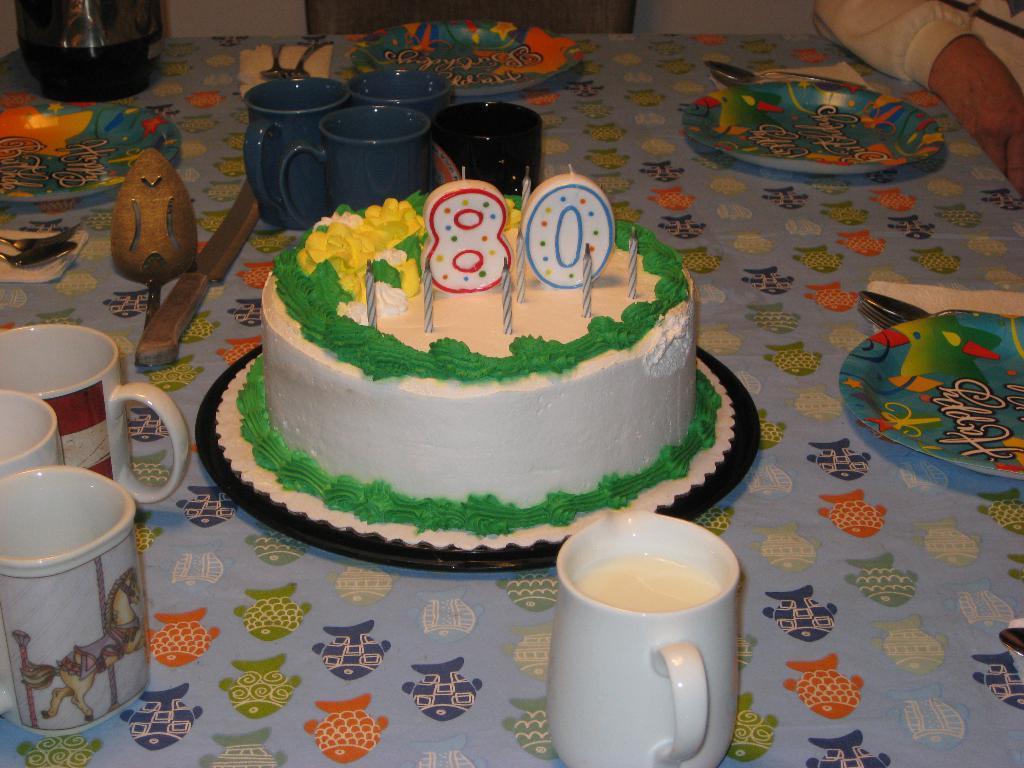Please provide a concise description of this image. In this image I can see the cake, cups, knife, plates, spoons and few objects on the table. I can see the person. 